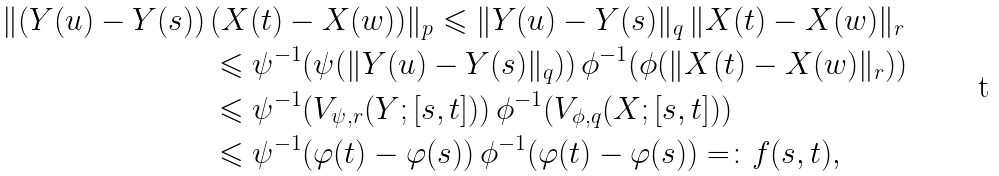<formula> <loc_0><loc_0><loc_500><loc_500>\| ( Y ( u ) - Y ( s ) ) \, & ( X ( t ) - X ( w ) ) \| _ { p } \leqslant \| Y ( u ) - Y ( s ) \| _ { q } \, \| X ( t ) - X ( w ) \| _ { r } \\ & \leqslant \psi ^ { - 1 } ( \psi ( \| Y ( u ) - Y ( s ) \| _ { q } ) ) \, \phi ^ { - 1 } ( \phi ( \| X ( t ) - X ( w ) \| _ { r } ) ) \\ & \leqslant \psi ^ { - 1 } ( V _ { \psi , r } ( Y ; [ s , t ] ) ) \, \phi ^ { - 1 } ( V _ { \phi , q } ( X ; [ s , t ] ) ) \\ & \leqslant \psi ^ { - 1 } ( \varphi ( t ) - \varphi ( s ) ) \, \phi ^ { - 1 } ( \varphi ( t ) - \varphi ( s ) ) = \colon f ( s , t ) ,</formula> 